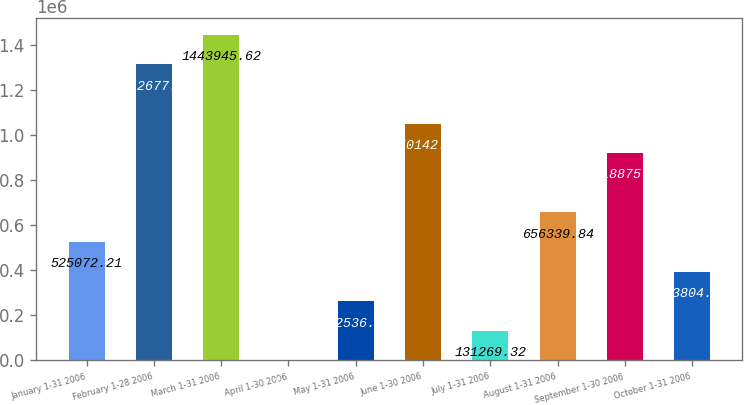<chart> <loc_0><loc_0><loc_500><loc_500><bar_chart><fcel>January 1-31 2006<fcel>February 1-28 2006<fcel>March 1-31 2006<fcel>April 1-30 2006<fcel>May 1-31 2006<fcel>June 1-30 2006<fcel>July 1-31 2006<fcel>August 1-31 2006<fcel>September 1-30 2006<fcel>October 1-31 2006<nl><fcel>525072<fcel>1.31268e+06<fcel>1.44395e+06<fcel>1.69<fcel>262537<fcel>1.05014e+06<fcel>131269<fcel>656340<fcel>918875<fcel>393805<nl></chart> 